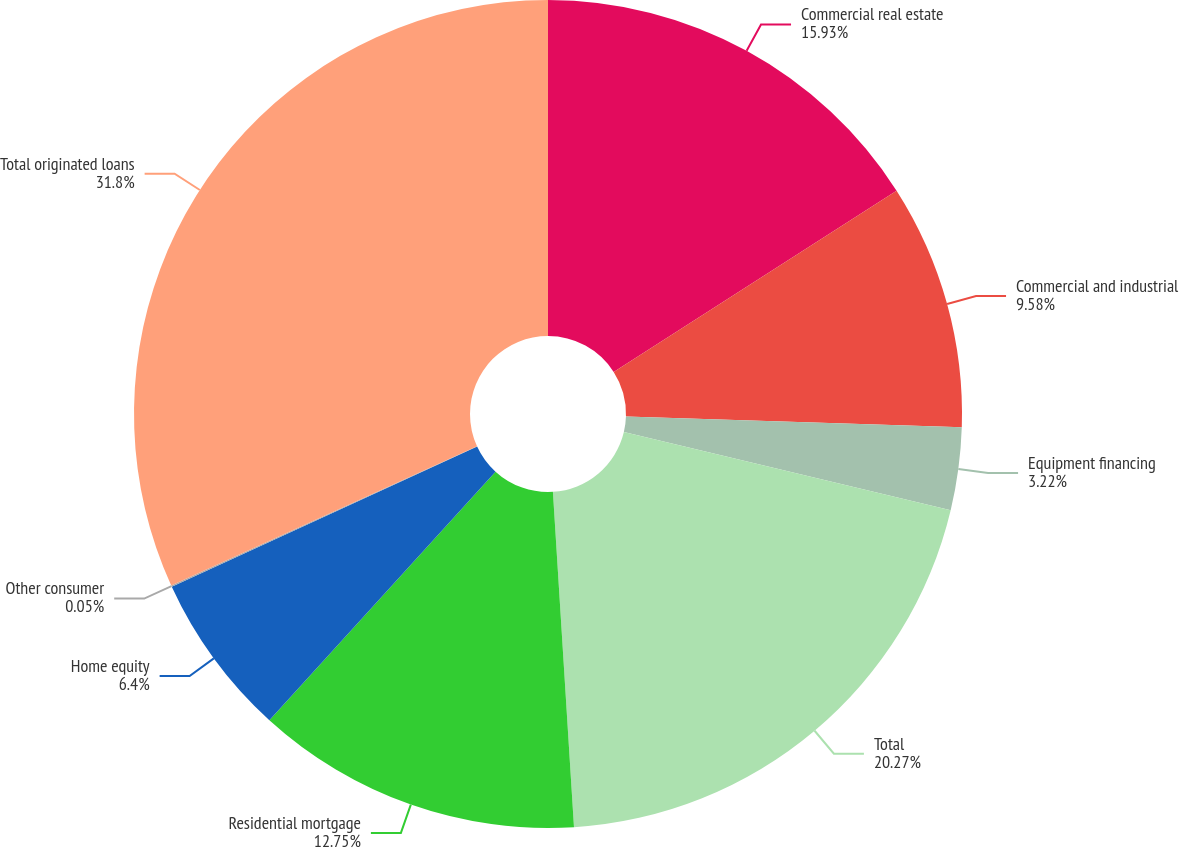Convert chart to OTSL. <chart><loc_0><loc_0><loc_500><loc_500><pie_chart><fcel>Commercial real estate<fcel>Commercial and industrial<fcel>Equipment financing<fcel>Total<fcel>Residential mortgage<fcel>Home equity<fcel>Other consumer<fcel>Total originated loans<nl><fcel>15.93%<fcel>9.58%<fcel>3.22%<fcel>20.27%<fcel>12.75%<fcel>6.4%<fcel>0.05%<fcel>31.8%<nl></chart> 